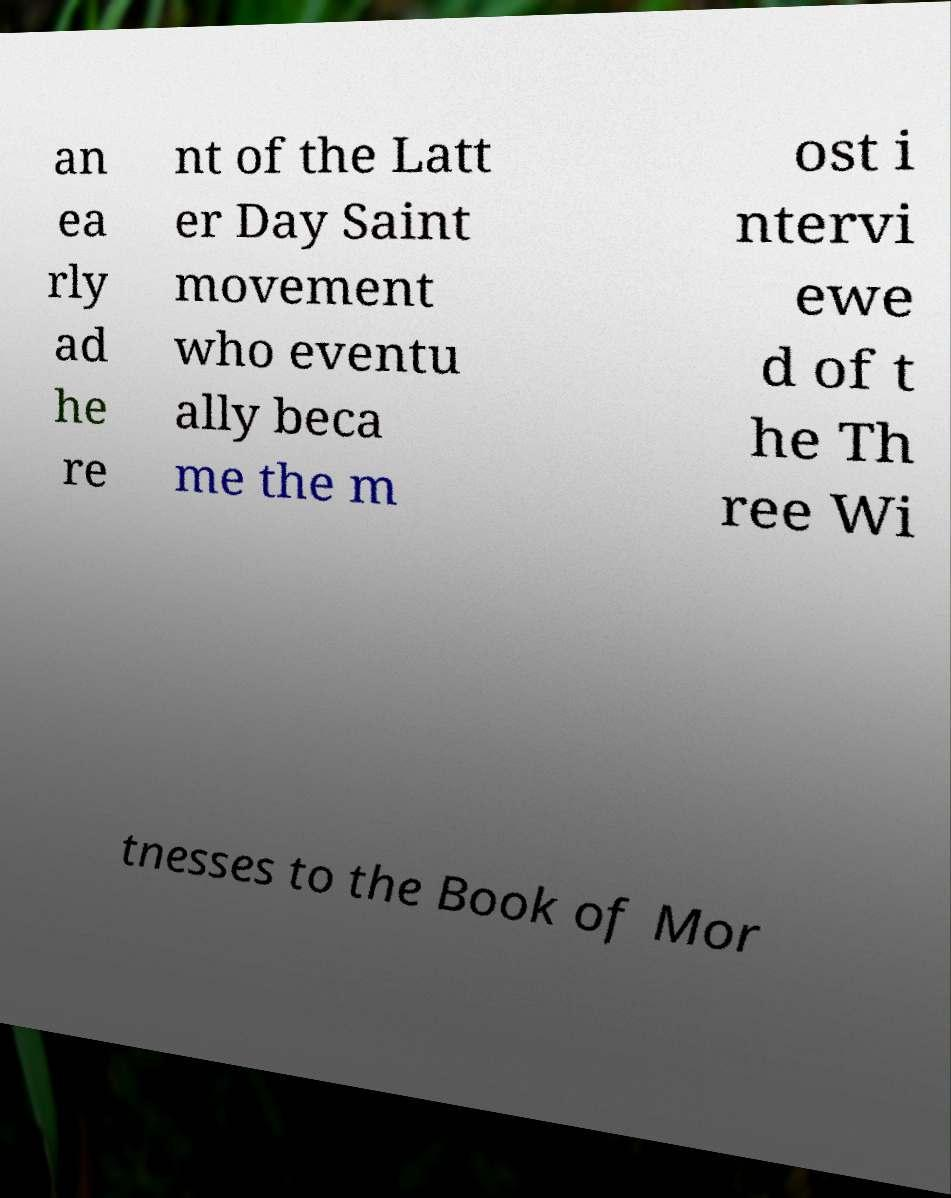Can you accurately transcribe the text from the provided image for me? an ea rly ad he re nt of the Latt er Day Saint movement who eventu ally beca me the m ost i ntervi ewe d of t he Th ree Wi tnesses to the Book of Mor 